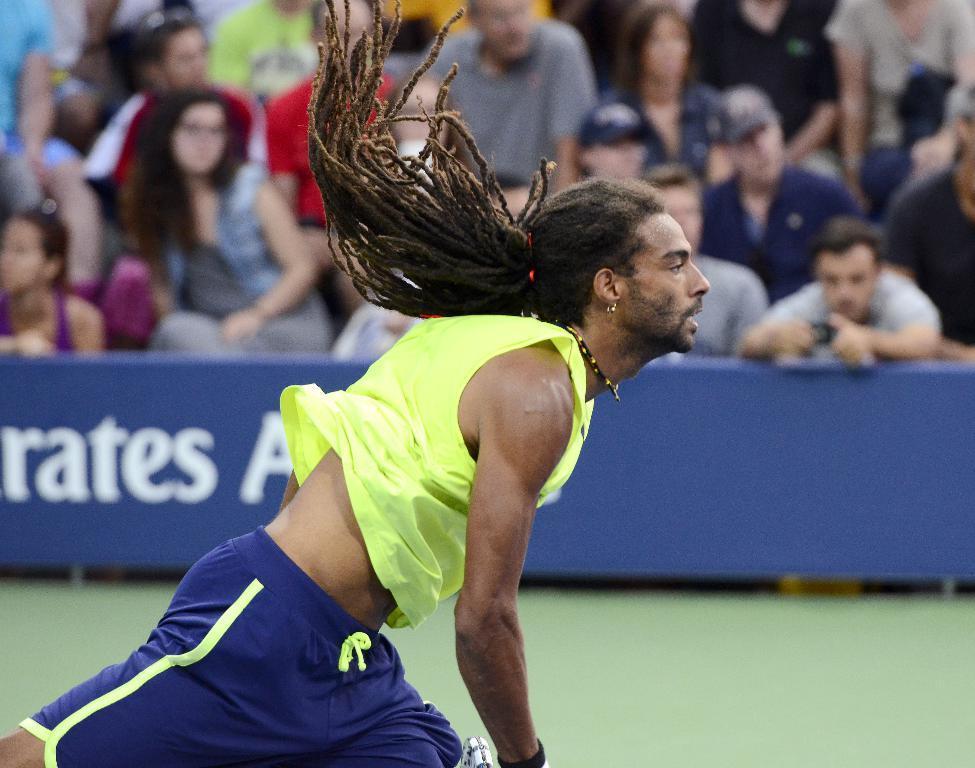Can you describe this image briefly? In this image there is a person running on the grassland. There is a banner having some text. Top of the image there are people. Right side there is a person holding an object. 